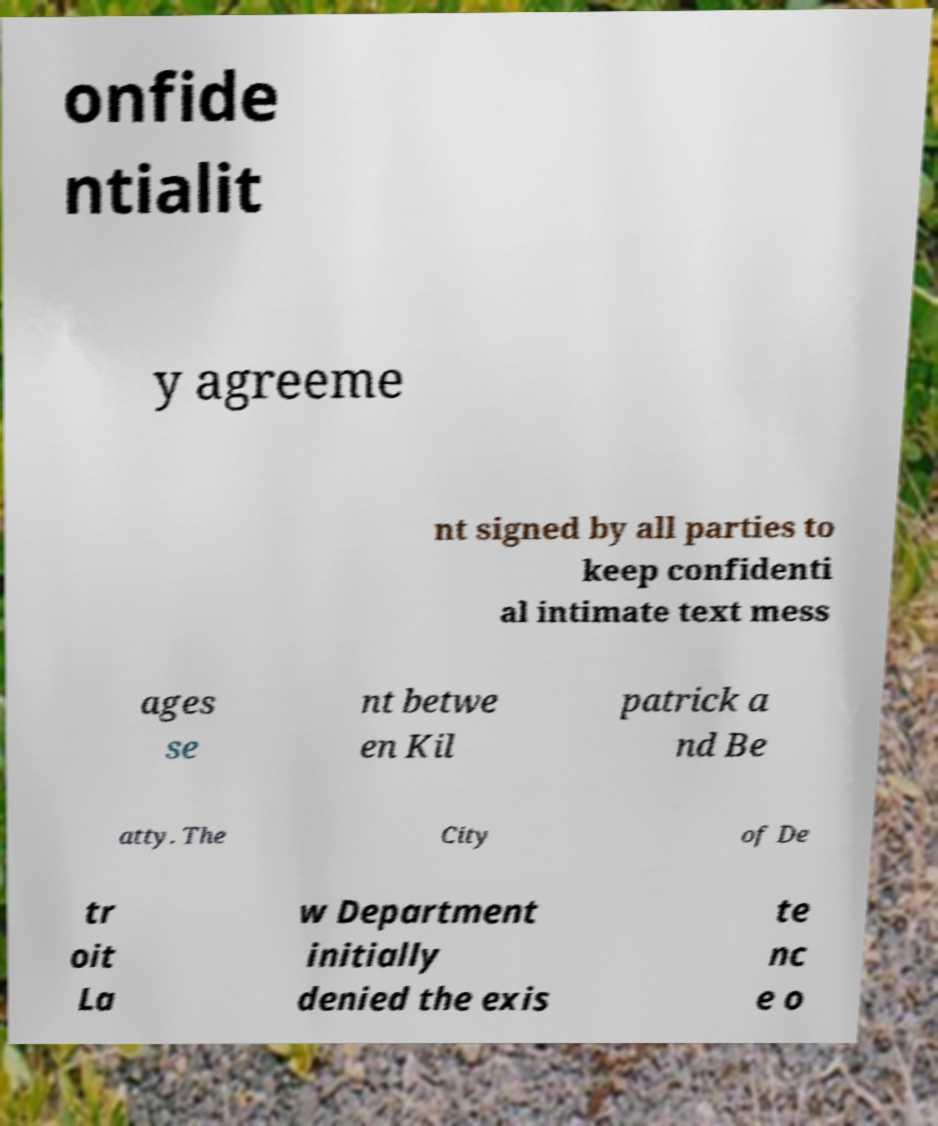For documentation purposes, I need the text within this image transcribed. Could you provide that? onfide ntialit y agreeme nt signed by all parties to keep confidenti al intimate text mess ages se nt betwe en Kil patrick a nd Be atty. The City of De tr oit La w Department initially denied the exis te nc e o 